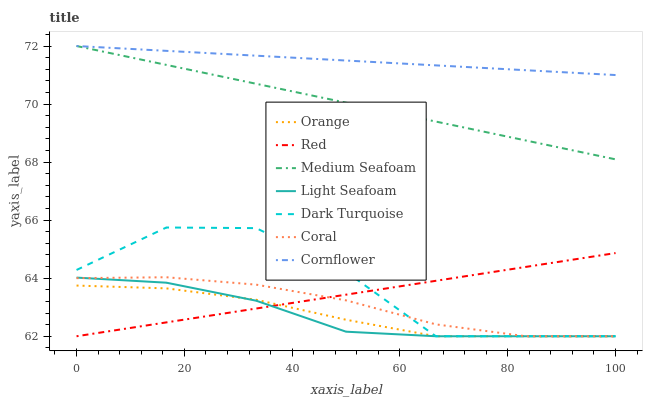Does Light Seafoam have the minimum area under the curve?
Answer yes or no. Yes. Does Cornflower have the maximum area under the curve?
Answer yes or no. Yes. Does Dark Turquoise have the minimum area under the curve?
Answer yes or no. No. Does Dark Turquoise have the maximum area under the curve?
Answer yes or no. No. Is Cornflower the smoothest?
Answer yes or no. Yes. Is Dark Turquoise the roughest?
Answer yes or no. Yes. Is Coral the smoothest?
Answer yes or no. No. Is Coral the roughest?
Answer yes or no. No. Does Medium Seafoam have the lowest value?
Answer yes or no. No. Does Dark Turquoise have the highest value?
Answer yes or no. No. Is Orange less than Medium Seafoam?
Answer yes or no. Yes. Is Cornflower greater than Coral?
Answer yes or no. Yes. Does Orange intersect Medium Seafoam?
Answer yes or no. No. 